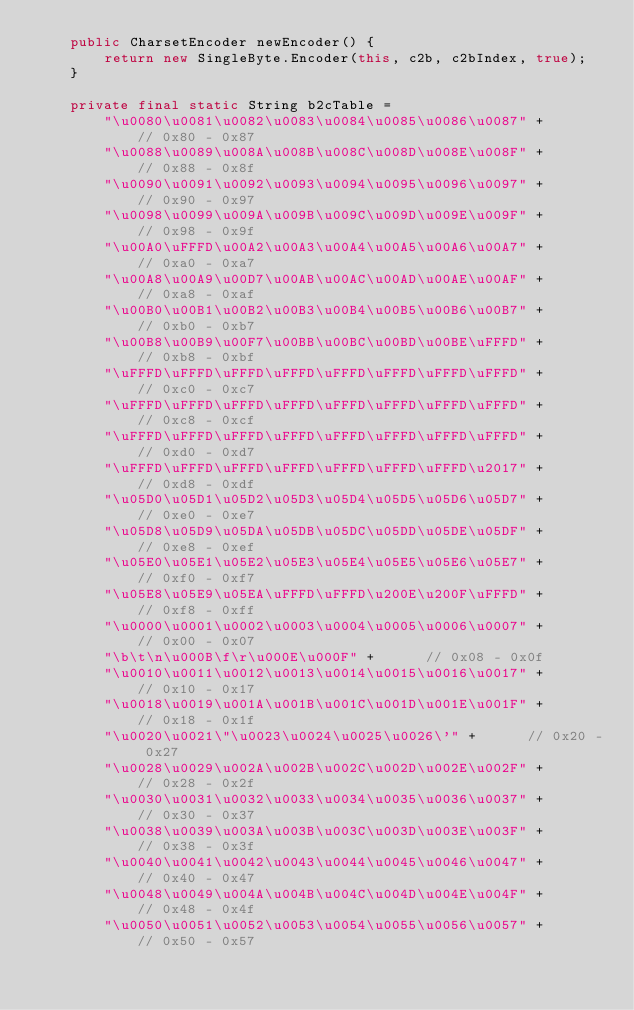Convert code to text. <code><loc_0><loc_0><loc_500><loc_500><_Java_>    public CharsetEncoder newEncoder() {
        return new SingleByte.Encoder(this, c2b, c2bIndex, true);
    }

    private final static String b2cTable = 
        "\u0080\u0081\u0082\u0083\u0084\u0085\u0086\u0087" +      // 0x80 - 0x87
        "\u0088\u0089\u008A\u008B\u008C\u008D\u008E\u008F" +      // 0x88 - 0x8f
        "\u0090\u0091\u0092\u0093\u0094\u0095\u0096\u0097" +      // 0x90 - 0x97
        "\u0098\u0099\u009A\u009B\u009C\u009D\u009E\u009F" +      // 0x98 - 0x9f
        "\u00A0\uFFFD\u00A2\u00A3\u00A4\u00A5\u00A6\u00A7" +      // 0xa0 - 0xa7
        "\u00A8\u00A9\u00D7\u00AB\u00AC\u00AD\u00AE\u00AF" +      // 0xa8 - 0xaf
        "\u00B0\u00B1\u00B2\u00B3\u00B4\u00B5\u00B6\u00B7" +      // 0xb0 - 0xb7
        "\u00B8\u00B9\u00F7\u00BB\u00BC\u00BD\u00BE\uFFFD" +      // 0xb8 - 0xbf
        "\uFFFD\uFFFD\uFFFD\uFFFD\uFFFD\uFFFD\uFFFD\uFFFD" +      // 0xc0 - 0xc7
        "\uFFFD\uFFFD\uFFFD\uFFFD\uFFFD\uFFFD\uFFFD\uFFFD" +      // 0xc8 - 0xcf
        "\uFFFD\uFFFD\uFFFD\uFFFD\uFFFD\uFFFD\uFFFD\uFFFD" +      // 0xd0 - 0xd7
        "\uFFFD\uFFFD\uFFFD\uFFFD\uFFFD\uFFFD\uFFFD\u2017" +      // 0xd8 - 0xdf
        "\u05D0\u05D1\u05D2\u05D3\u05D4\u05D5\u05D6\u05D7" +      // 0xe0 - 0xe7
        "\u05D8\u05D9\u05DA\u05DB\u05DC\u05DD\u05DE\u05DF" +      // 0xe8 - 0xef
        "\u05E0\u05E1\u05E2\u05E3\u05E4\u05E5\u05E6\u05E7" +      // 0xf0 - 0xf7
        "\u05E8\u05E9\u05EA\uFFFD\uFFFD\u200E\u200F\uFFFD" +      // 0xf8 - 0xff
        "\u0000\u0001\u0002\u0003\u0004\u0005\u0006\u0007" +      // 0x00 - 0x07
        "\b\t\n\u000B\f\r\u000E\u000F" +      // 0x08 - 0x0f
        "\u0010\u0011\u0012\u0013\u0014\u0015\u0016\u0017" +      // 0x10 - 0x17
        "\u0018\u0019\u001A\u001B\u001C\u001D\u001E\u001F" +      // 0x18 - 0x1f
        "\u0020\u0021\"\u0023\u0024\u0025\u0026\'" +      // 0x20 - 0x27
        "\u0028\u0029\u002A\u002B\u002C\u002D\u002E\u002F" +      // 0x28 - 0x2f
        "\u0030\u0031\u0032\u0033\u0034\u0035\u0036\u0037" +      // 0x30 - 0x37
        "\u0038\u0039\u003A\u003B\u003C\u003D\u003E\u003F" +      // 0x38 - 0x3f
        "\u0040\u0041\u0042\u0043\u0044\u0045\u0046\u0047" +      // 0x40 - 0x47
        "\u0048\u0049\u004A\u004B\u004C\u004D\u004E\u004F" +      // 0x48 - 0x4f
        "\u0050\u0051\u0052\u0053\u0054\u0055\u0056\u0057" +      // 0x50 - 0x57</code> 